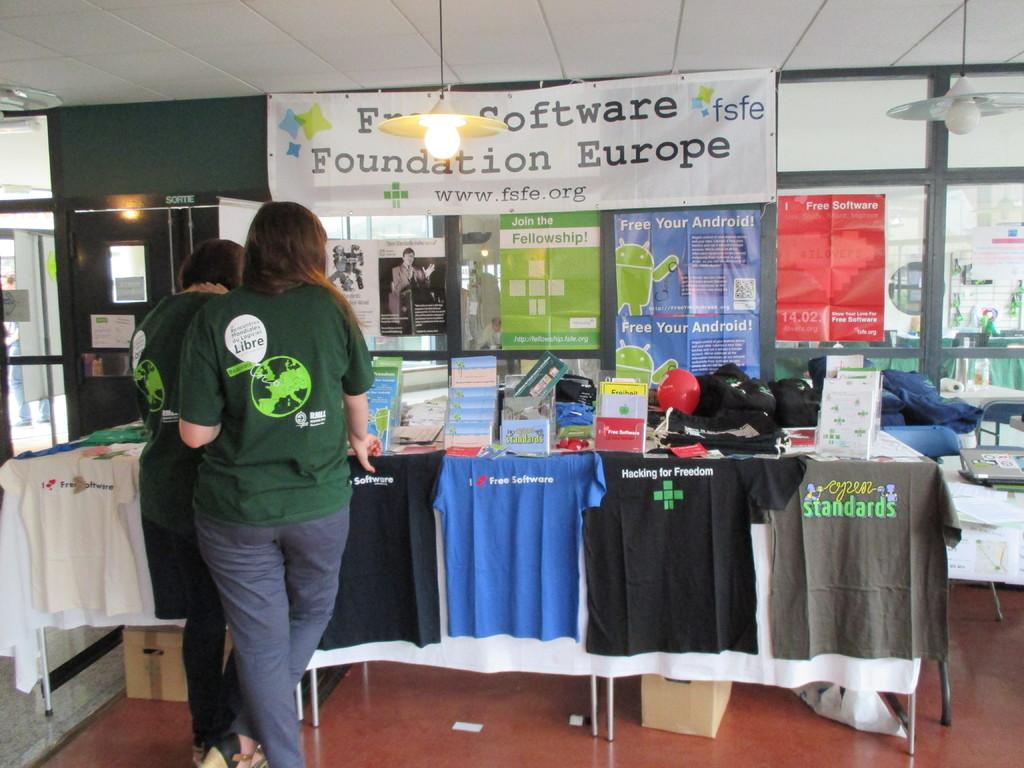What country does the sign display?
Provide a succinct answer. Europe. 